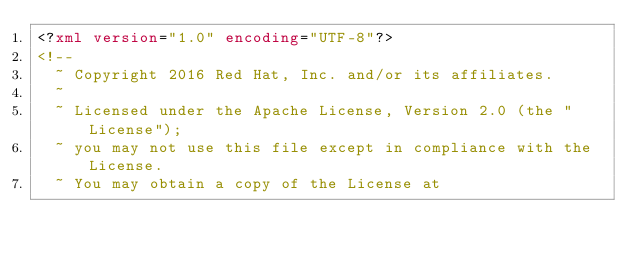<code> <loc_0><loc_0><loc_500><loc_500><_XML_><?xml version="1.0" encoding="UTF-8"?>
<!--
  ~ Copyright 2016 Red Hat, Inc. and/or its affiliates.
  ~
  ~ Licensed under the Apache License, Version 2.0 (the "License");
  ~ you may not use this file except in compliance with the License.
  ~ You may obtain a copy of the License at</code> 